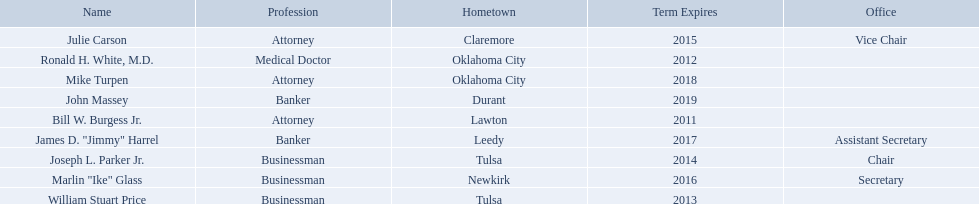Who are the businessmen? Bill W. Burgess Jr., Ronald H. White, M.D., William Stuart Price, Joseph L. Parker Jr., Julie Carson, Marlin "Ike" Glass, James D. "Jimmy" Harrel, Mike Turpen, John Massey. Which were born in tulsa? William Stuart Price, Joseph L. Parker Jr. Of these, which one was other than william stuart price? Joseph L. Parker Jr. 